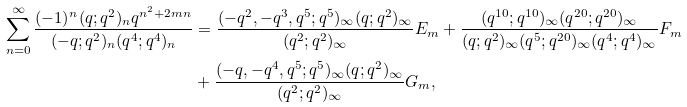<formula> <loc_0><loc_0><loc_500><loc_500>\sum _ { n = 0 } ^ { \infty } \frac { ( - 1 ) ^ { n } ( q ; q ^ { 2 } ) _ { n } q ^ { n ^ { 2 } + 2 m n } } { ( - q ; q ^ { 2 } ) _ { n } ( q ^ { 4 } ; q ^ { 4 } ) _ { n } } & = \frac { ( - q ^ { 2 } , - q ^ { 3 } , q ^ { 5 } ; q ^ { 5 } ) _ { \infty } ( q ; q ^ { 2 } ) _ { \infty } } { ( q ^ { 2 } ; q ^ { 2 } ) _ { \infty } } E _ { m } + \frac { ( q ^ { 1 0 } ; q ^ { 1 0 } ) _ { \infty } ( q ^ { 2 0 } ; q ^ { 2 0 } ) _ { \infty } } { ( q ; q ^ { 2 } ) _ { \infty } ( q ^ { 5 } ; q ^ { 2 0 } ) _ { \infty } ( q ^ { 4 } ; q ^ { 4 } ) _ { \infty } } F _ { m } \\ & + \frac { ( - q , - q ^ { 4 } , q ^ { 5 } ; q ^ { 5 } ) _ { \infty } ( q ; q ^ { 2 } ) _ { \infty } } { ( q ^ { 2 } ; q ^ { 2 } ) _ { \infty } } G _ { m } ,</formula> 